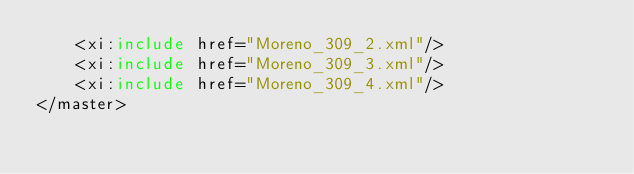Convert code to text. <code><loc_0><loc_0><loc_500><loc_500><_XML_>    <xi:include href="Moreno_309_2.xml"/>
    <xi:include href="Moreno_309_3.xml"/>
    <xi:include href="Moreno_309_4.xml"/>
</master>
</code> 